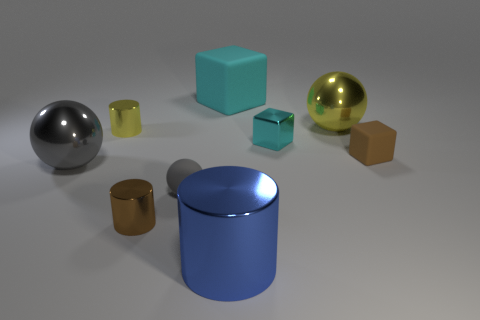Is the number of cyan matte spheres greater than the number of small brown matte blocks?
Your response must be concise. No. What number of other objects are there of the same color as the small sphere?
Keep it short and to the point. 1. What number of metallic things are both in front of the tiny gray rubber object and behind the tiny brown cylinder?
Your answer should be compact. 0. Are there any other things that are the same size as the blue object?
Give a very brief answer. Yes. Is the number of large cubes left of the small gray object greater than the number of large matte objects that are to the right of the big blue cylinder?
Make the answer very short. No. What is the large thing that is on the left side of the big block made of?
Your response must be concise. Metal. Does the tiny gray object have the same shape as the yellow thing to the left of the large yellow ball?
Offer a terse response. No. How many tiny yellow metal things are left of the cyan thing in front of the object behind the big yellow metal sphere?
Offer a terse response. 1. There is another tiny matte thing that is the same shape as the cyan matte object; what color is it?
Give a very brief answer. Brown. Is there anything else that has the same shape as the large yellow thing?
Make the answer very short. Yes. 